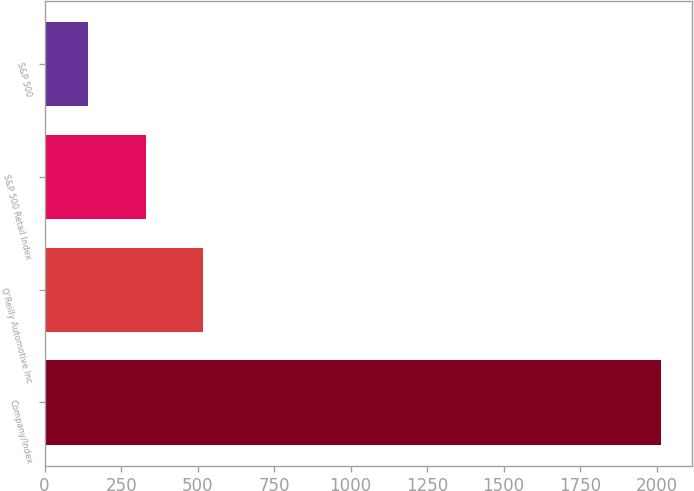<chart> <loc_0><loc_0><loc_500><loc_500><bar_chart><fcel>Company/Index<fcel>O'Reilly Automotive Inc<fcel>S&P 500 Retail Index<fcel>S&P 500<nl><fcel>2015<fcel>517.4<fcel>330.2<fcel>143<nl></chart> 